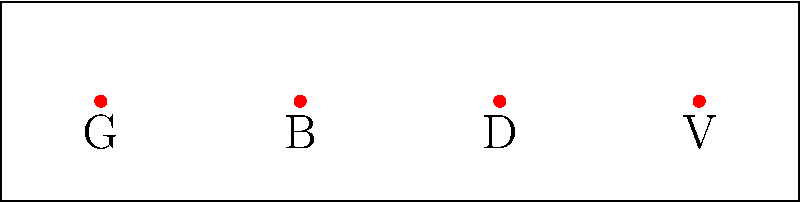Consider a rock band with four members: guitarist (G), bassist (B), drummer (D), and vocalist (V). The diagram shows their initial stage positions. How many unique permutations (different arrangements) of the band members are possible, assuming each member must occupy one of the four positions? To solve this problem, we'll use the concept of permutations from group theory:

1. We have 4 distinct positions and 4 distinct band members.
2. Each position must be filled by exactly one band member.
3. The number of ways to arrange n distinct objects is given by n!

In this case:
4! = 4 × 3 × 2 × 1 = 24

Step-by-step breakdown:
1. First position: 4 choices
2. Second position: 3 remaining choices
3. Third position: 2 remaining choices
4. Fourth position: Only 1 choice left

Multiplying these together: 4 × 3 × 2 × 1 = 24

This means there are 24 different ways the band members can arrange themselves on stage, each creating a unique permutation in the permutation group $S_4$ (the symmetric group on 4 elements).

Some examples of these permutations in cycle notation:
- Identity: (1)
- Swapping guitarist and bassist: (GB)
- Rotating everyone one position to the right: (GVDB)

Each of these permutations corresponds to a unique stage arrangement of the band members.
Answer: 24 